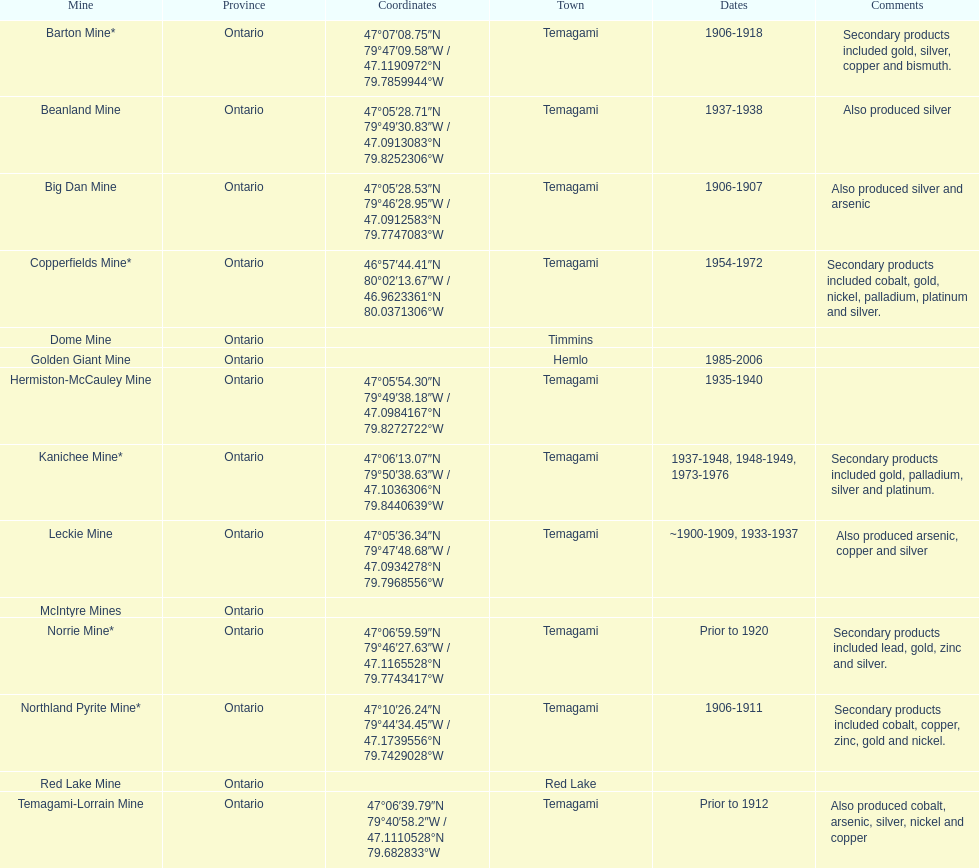Name a gold mine that was open at least 10 years. Barton Mine. 